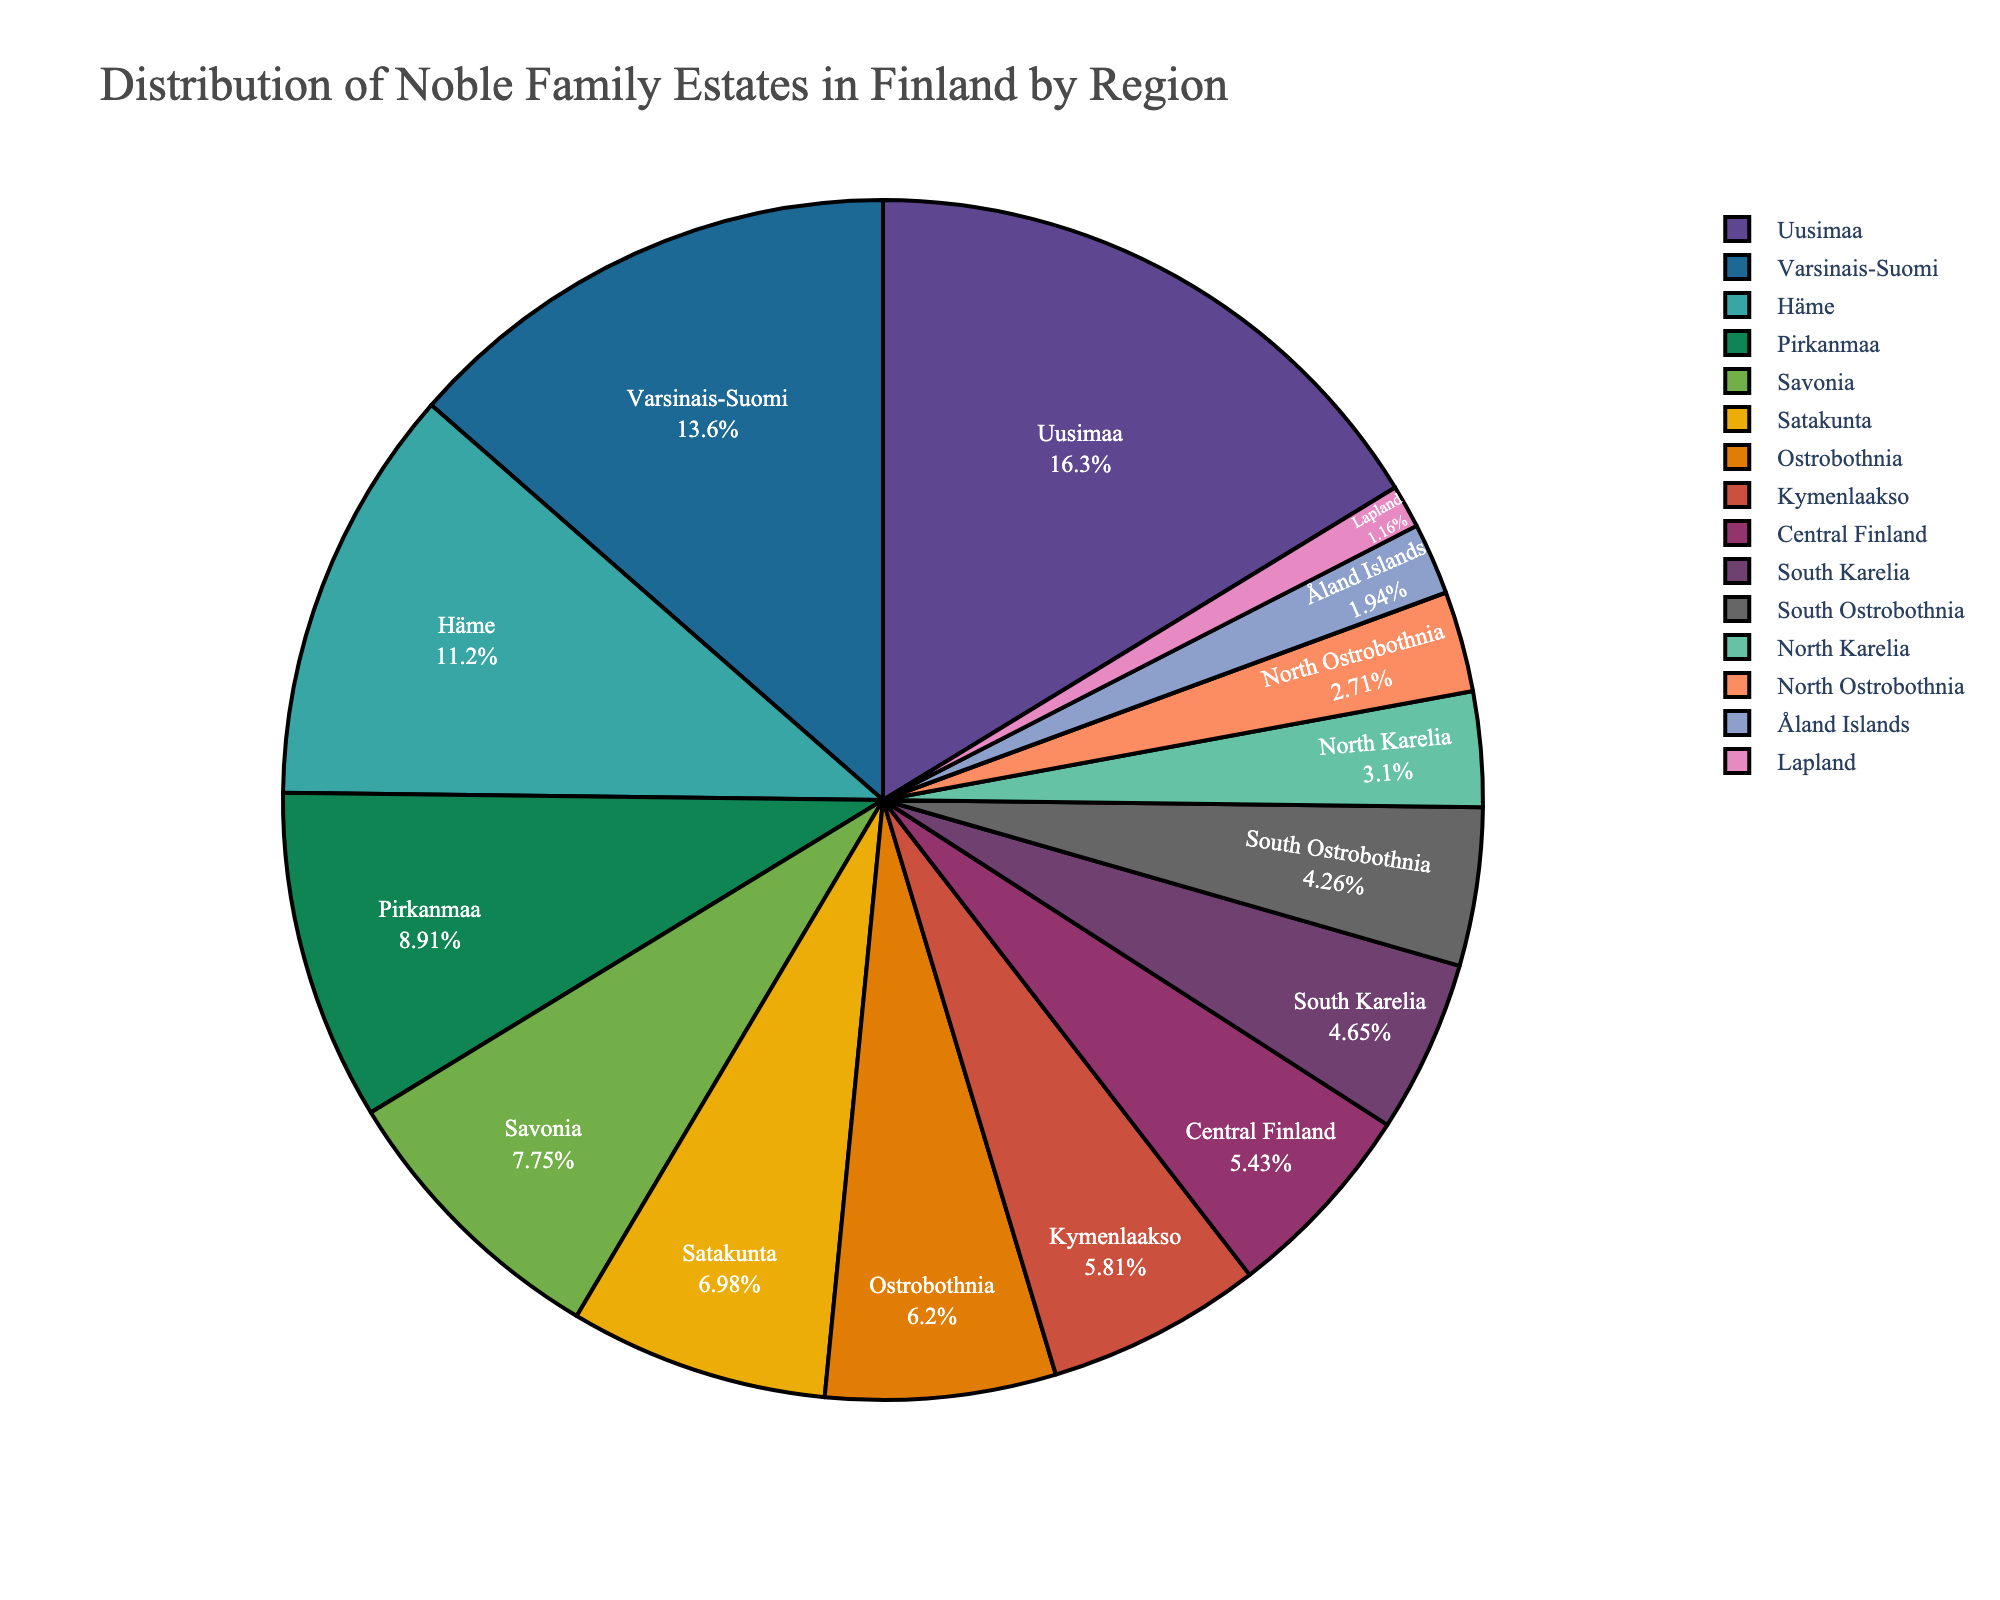What region has the most noble family estates? The region with the largest slice of the pie chart indicates the highest number of noble family estates. In this case, it is Uusimaa.
Answer: Uusimaa Which two regions combined have almost the same number of estates as Häme? Häme has 29 estates. Combined estates of Central Finland (14) and Ostrobothnia (16) are 14 + 16 = 30, which is almost equal to 29.
Answer: Central Finland and Ostrobothnia What is the percentage of noble family estates in Varsinais-Suomi? Refer to the pie chart section for Varsinais-Suomi. It is visually displayed as 16.3% of the total estates.
Answer: 16.3% Which region has the least number of noble family estates? The smallest slice of the pie chart indicates the region with the least number of estates. In this case, it is Lapland.
Answer: Lapland Compare the number of estates in Pirkanmaa and Kymenlaakso. Which has more, and by how many? Pirkanmaa has 23 estates, while Kymenlaakso has 15. The difference is 23 - 15 = 8.
Answer: Pirkanmaa by 8 How many estates are there in South Karelia and North Karelia combined? South Karelia has 12 estates and North Karelia has 8. So, combined they have 12 + 8 = 20 estates.
Answer: 20 Which region has slightly fewer estates than Satakunta? Satakunta has 18 estates. The region with slightly fewer estates is Ostrobothnia with 16 estates.
Answer: Ostrobothnia What regions have exactly half the number of estates as Uusimaa? Uusimaa has 42 estates. Half of 42 is 21. The closest region is Pirkanmaa with 23 estates, though there is no exact match.
Answer: None By visual comparison, what is the approximate difference in the number of estates between Åland Islands and North Ostrobothnia? Åland Islands have 5 estates, North Ostrobothnia has 7. The difference is 7 - 5 = 2.
Answer: 2 If you combine the number of estates in South Ostrobothnia and Lapland, is this combination less than those in Varsinais-Suomi? South Ostrobothnia has 11 estates and Lapland has 3, together they make 11 + 3 = 14 estates. Varsinais-Suomi has 35 estates, so 14 is less than 35.
Answer: Yes 